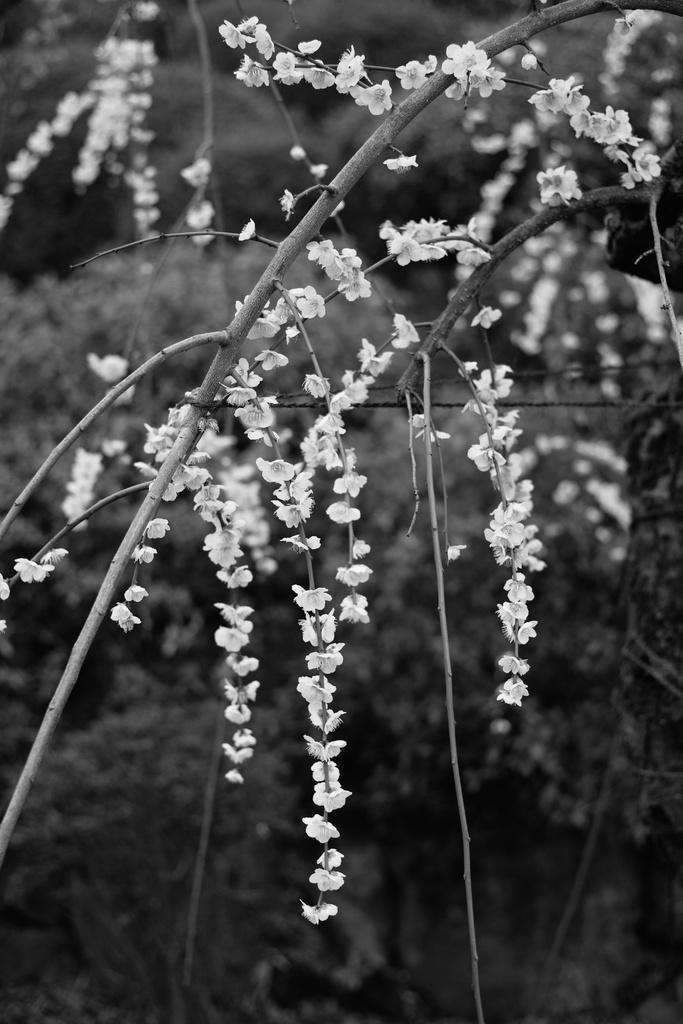Could you give a brief overview of what you see in this image? This image consists of a plant. To which we can see the white color flowers. The background is blurred. 